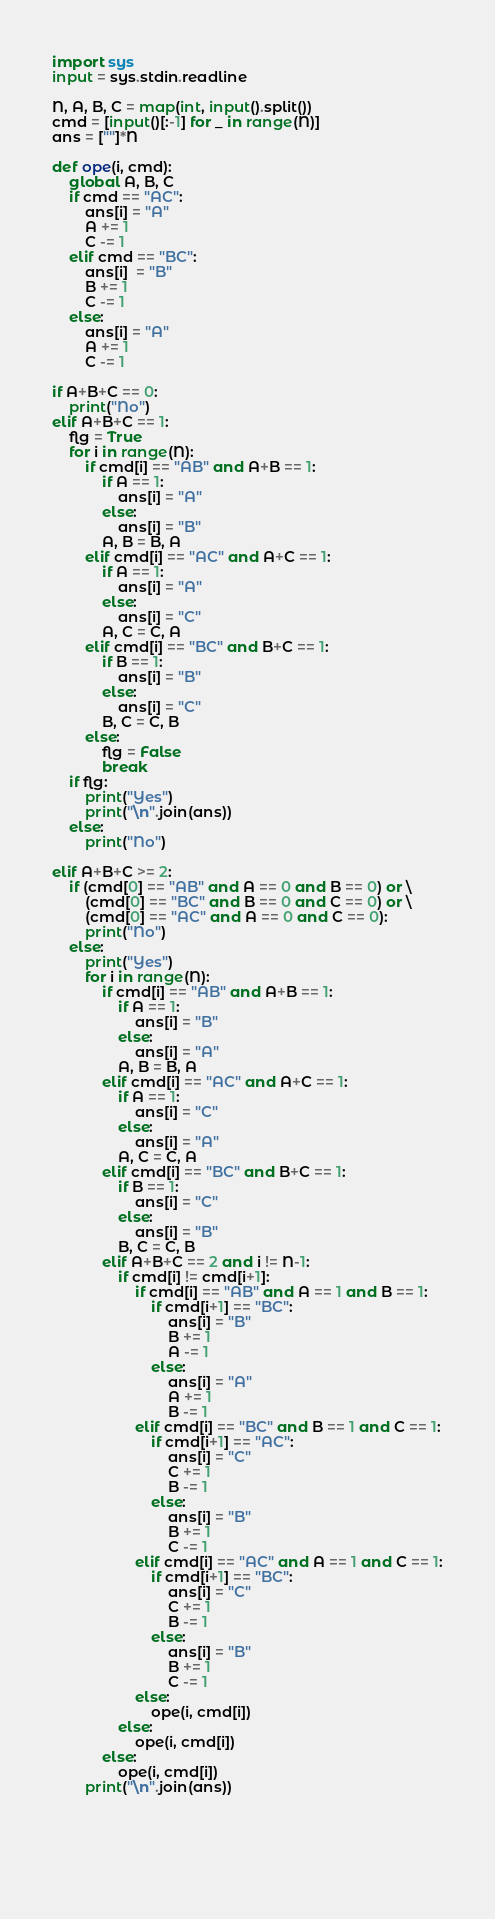<code> <loc_0><loc_0><loc_500><loc_500><_Python_>import sys
input = sys.stdin.readline

N, A, B, C = map(int, input().split())
cmd = [input()[:-1] for _ in range(N)]
ans = [""]*N

def ope(i, cmd):
    global A, B, C
    if cmd == "AC":
        ans[i] = "A"
        A += 1
        C -= 1
    elif cmd == "BC":
        ans[i]  = "B"
        B += 1
        C -= 1
    else:
        ans[i] = "A"
        A += 1
        C -= 1

if A+B+C == 0:
    print("No")
elif A+B+C == 1:
    flg = True
    for i in range(N):
        if cmd[i] == "AB" and A+B == 1:
            if A == 1:
                ans[i] = "A"
            else:
                ans[i] = "B"
            A, B = B, A
        elif cmd[i] == "AC" and A+C == 1:
            if A == 1:
                ans[i] = "A"
            else:
                ans[i] = "C"
            A, C = C, A
        elif cmd[i] == "BC" and B+C == 1:
            if B == 1:
                ans[i] = "B"
            else:
                ans[i] = "C"
            B, C = C, B
        else:
            flg = False
            break 
    if flg:
        print("Yes")
        print("\n".join(ans))
    else:
        print("No")

elif A+B+C >= 2:
    if (cmd[0] == "AB" and A == 0 and B == 0) or \
        (cmd[0] == "BC" and B == 0 and C == 0) or \
        (cmd[0] == "AC" and A == 0 and C == 0):
        print("No")
    else:
        print("Yes")
        for i in range(N):
            if cmd[i] == "AB" and A+B == 1:
                if A == 1:
                    ans[i] = "B"
                else:
                    ans[i] = "A"
                A, B = B, A
            elif cmd[i] == "AC" and A+C == 1:
                if A == 1:
                    ans[i] = "C"
                else:
                    ans[i] = "A"
                A, C = C, A
            elif cmd[i] == "BC" and B+C == 1:
                if B == 1:
                    ans[i] = "C"
                else:
                    ans[i] = "B"
                B, C = C, B
            elif A+B+C == 2 and i != N-1:
                if cmd[i] != cmd[i+1]:
                    if cmd[i] == "AB" and A == 1 and B == 1:
                        if cmd[i+1] == "BC":
                            ans[i] = "B"
                            B += 1
                            A -= 1
                        else:
                            ans[i] = "A"
                            A += 1
                            B -= 1
                    elif cmd[i] == "BC" and B == 1 and C == 1:
                        if cmd[i+1] == "AC":
                            ans[i] = "C"
                            C += 1
                            B -= 1
                        else:
                            ans[i] = "B"
                            B += 1
                            C -= 1
                    elif cmd[i] == "AC" and A == 1 and C == 1:
                        if cmd[i+1] == "BC":
                            ans[i] = "C"
                            C += 1
                            B -= 1
                        else:
                            ans[i] = "B"
                            B += 1
                            C -= 1
                    else:
                        ope(i, cmd[i])
                else:
                    ope(i, cmd[i])
            else:
                ope(i, cmd[i])
        print("\n".join(ans))


                
                
                
</code> 